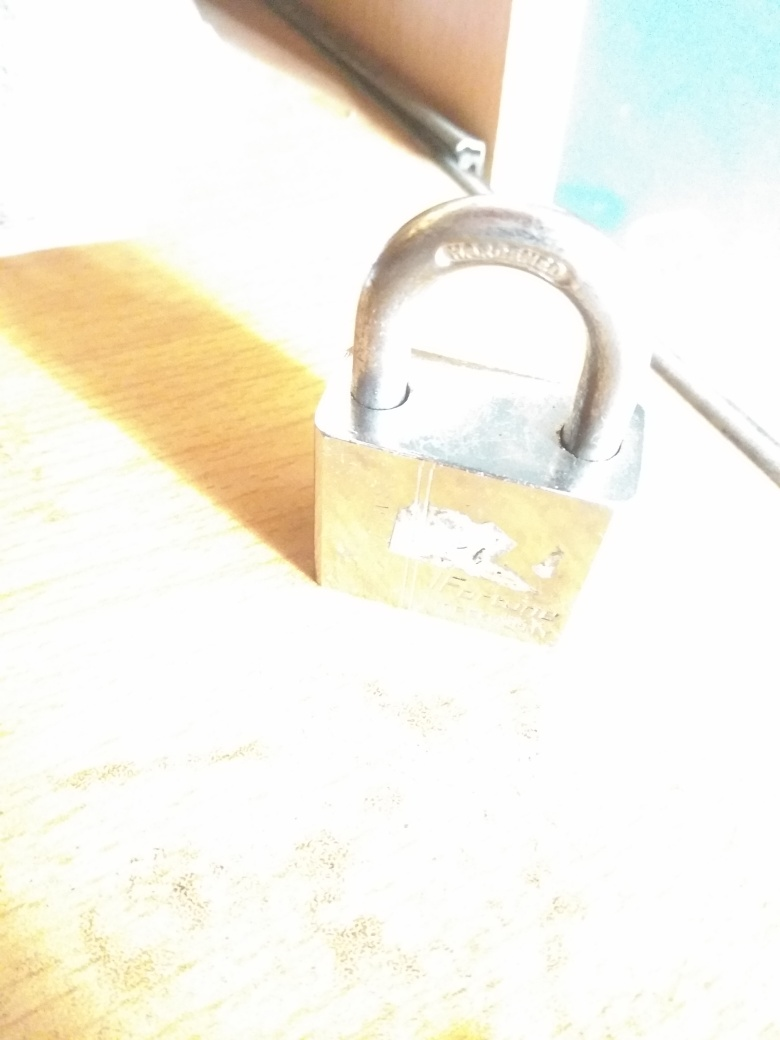What can be said about the subject's appearance? The subject in the image – a padlock – is depicted with an overexposed lighting condition, which causes the features to appear washed out and lacking in detail. The bright light obscures the finer elements, rendering parts of the padlock blurry rather than offering a crisp and clearly focused representation. 